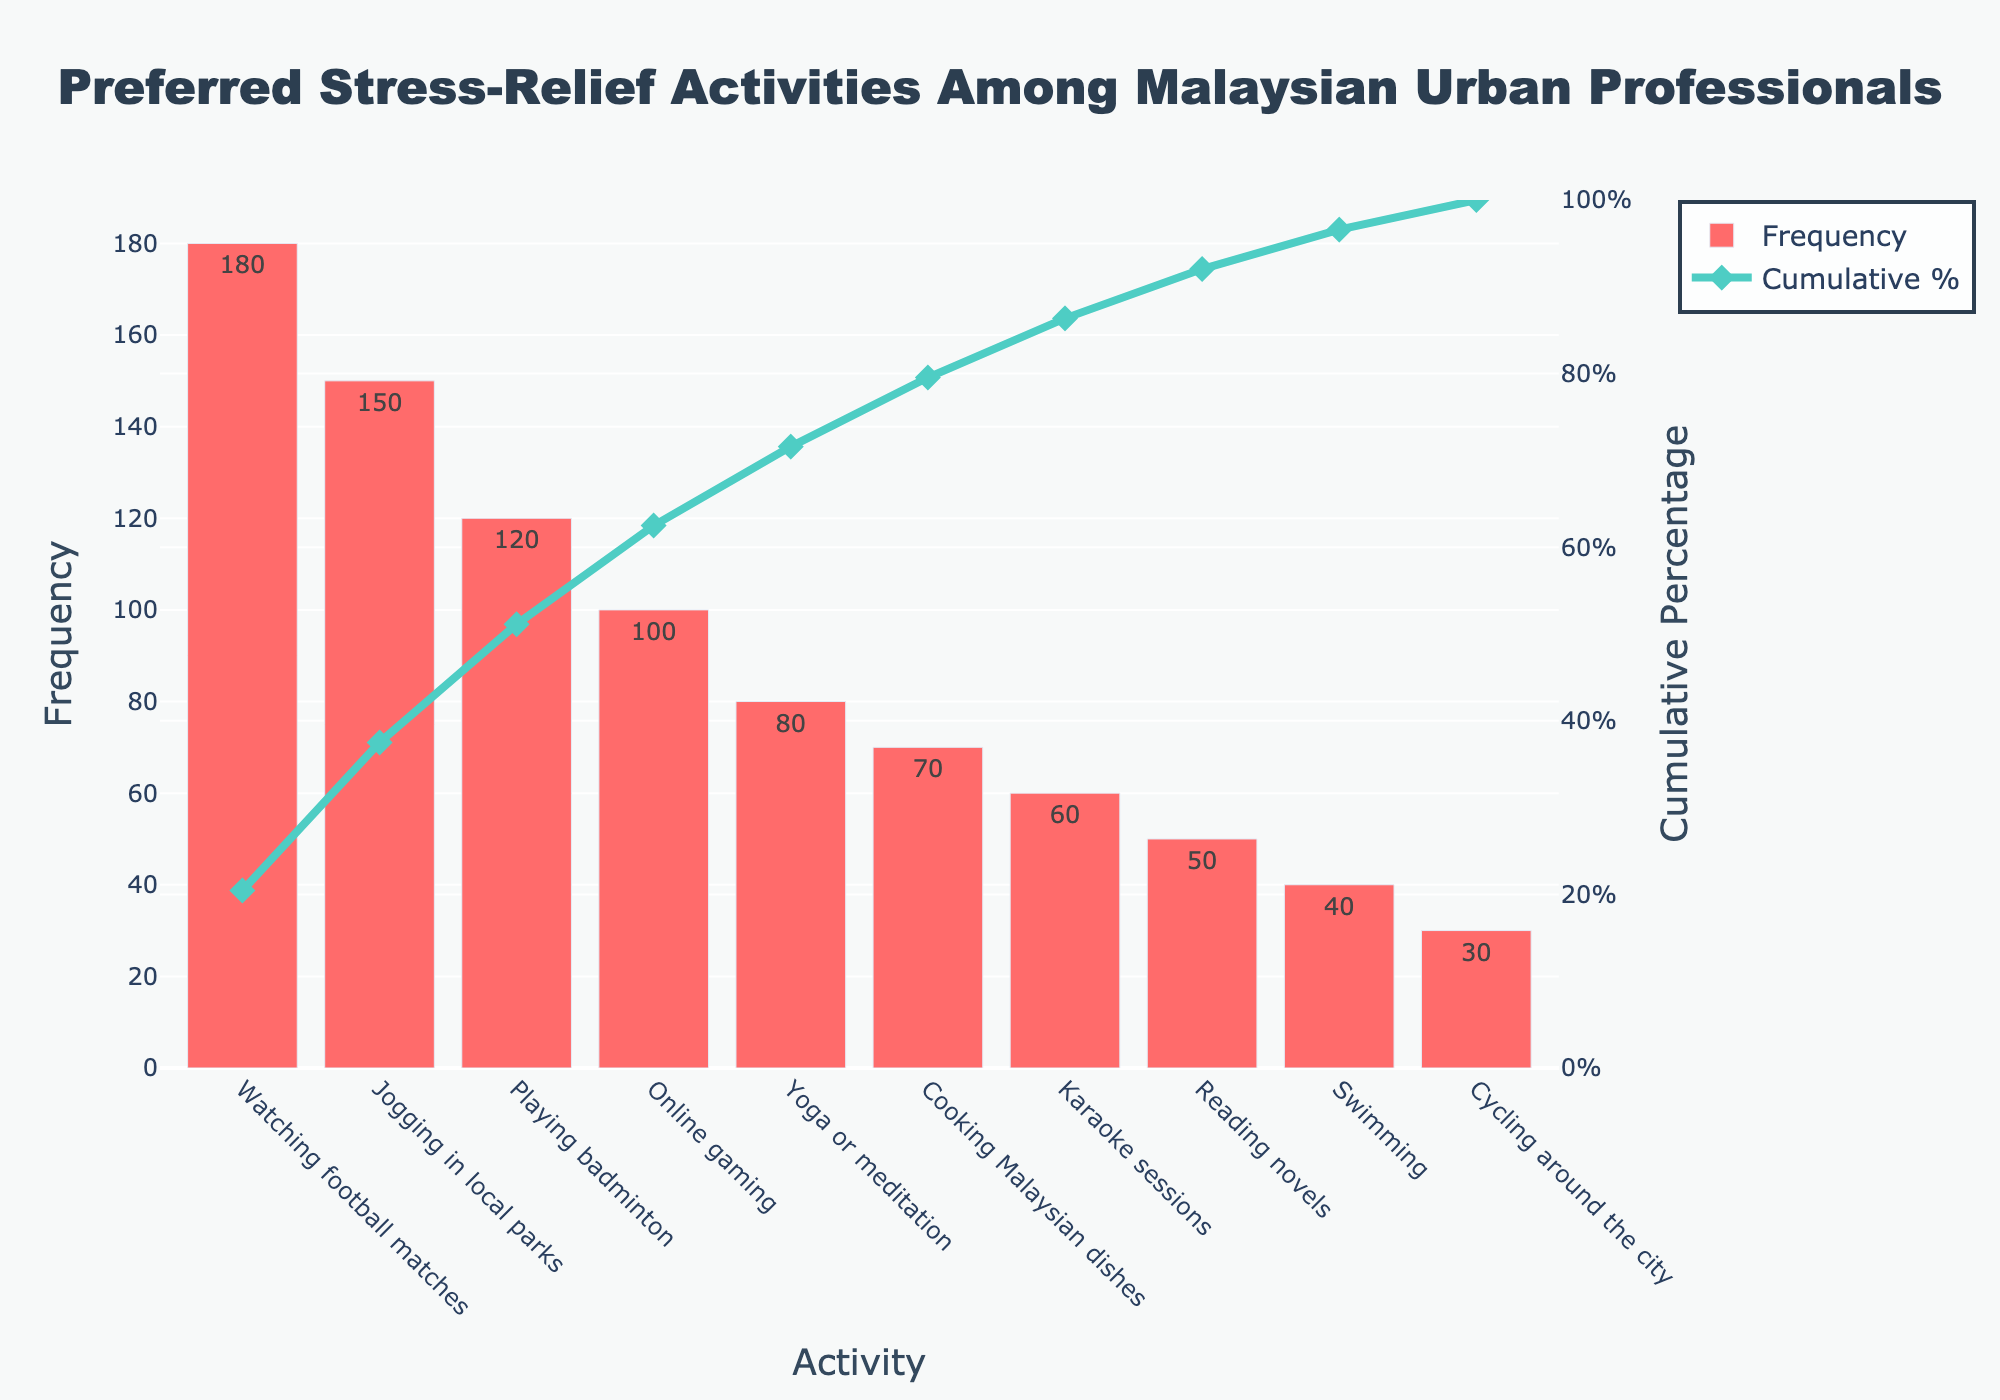What is the most common stress-relief activity among Malaysian urban professionals? Look at the bar chart and identify the activity with the highest bar. The highest bar corresponds to "Watching football matches" with a frequency of 180.
Answer: Watching football matches How many activities have a frequency greater than or equal to 100? Look at the bars with frequencies labeled. From the chart, the activities "Watching football matches" (180), "Jogging in local parks" (150), "Playing badminton" (120), and "Online gaming" (100) meet the criteria.
Answer: 4 What is the cumulative percentage for Playing badminton? Locate the bar for "Playing badminton" and refer to the line chart that intersects with it. The cumulative percentage is close to or exactly 68.8%.
Answer: 68.8% How does the frequency of Cooking Malaysian dishes compare to Yoga or meditation? Look at the height of the bars for both activities. The frequency for "Yoga or meditation" is 80, and for "Cooking Malaysian dishes" it is 70.
Answer: Cooking Malaysian dishes is less frequent than Yoga or meditation What percentage of people prefer either Online gaming, Yoga or meditation, or Cooking Malaysian dishes as their stress-relief activity? Add the frequencies for the three activities: 100 (Online gaming) + 80 (Yoga or meditation) + 70 (Cooking Malaysian dishes) = 250. Find this as a percentage of the total (900). (250/900) * 100 = 27.78%
Answer: 27.78% Which activity marks the point where the cumulative percentage exceeds 50%? Examine the cumulative percentage line on the chart to see where it first surpasses the 50% mark. This happens at "Playing badminton" around 68.8%.
Answer: Playing badminton What is the difference in frequency between the most and least preferred activities? Identify the highest frequency (Watching football matches) and the lowest (Cycling around the city). The difference is 180 - 30 = 150.
Answer: 150 If you sum the frequencies of the two least common activities, what is the cumulative percentage of this total? The two least common activities are "Cycling around the city" (30) and "Swimming" (40). The sum is 70. The cumulative percentage for 70 is found at "Yoga or meditation," which is the next activity on the chart and just for ease let’s assume its cumulative percentage is the same for "Cooking Malaysian dishes" which is close to 83.3% from the information.
Answer: Close to 83.3% 